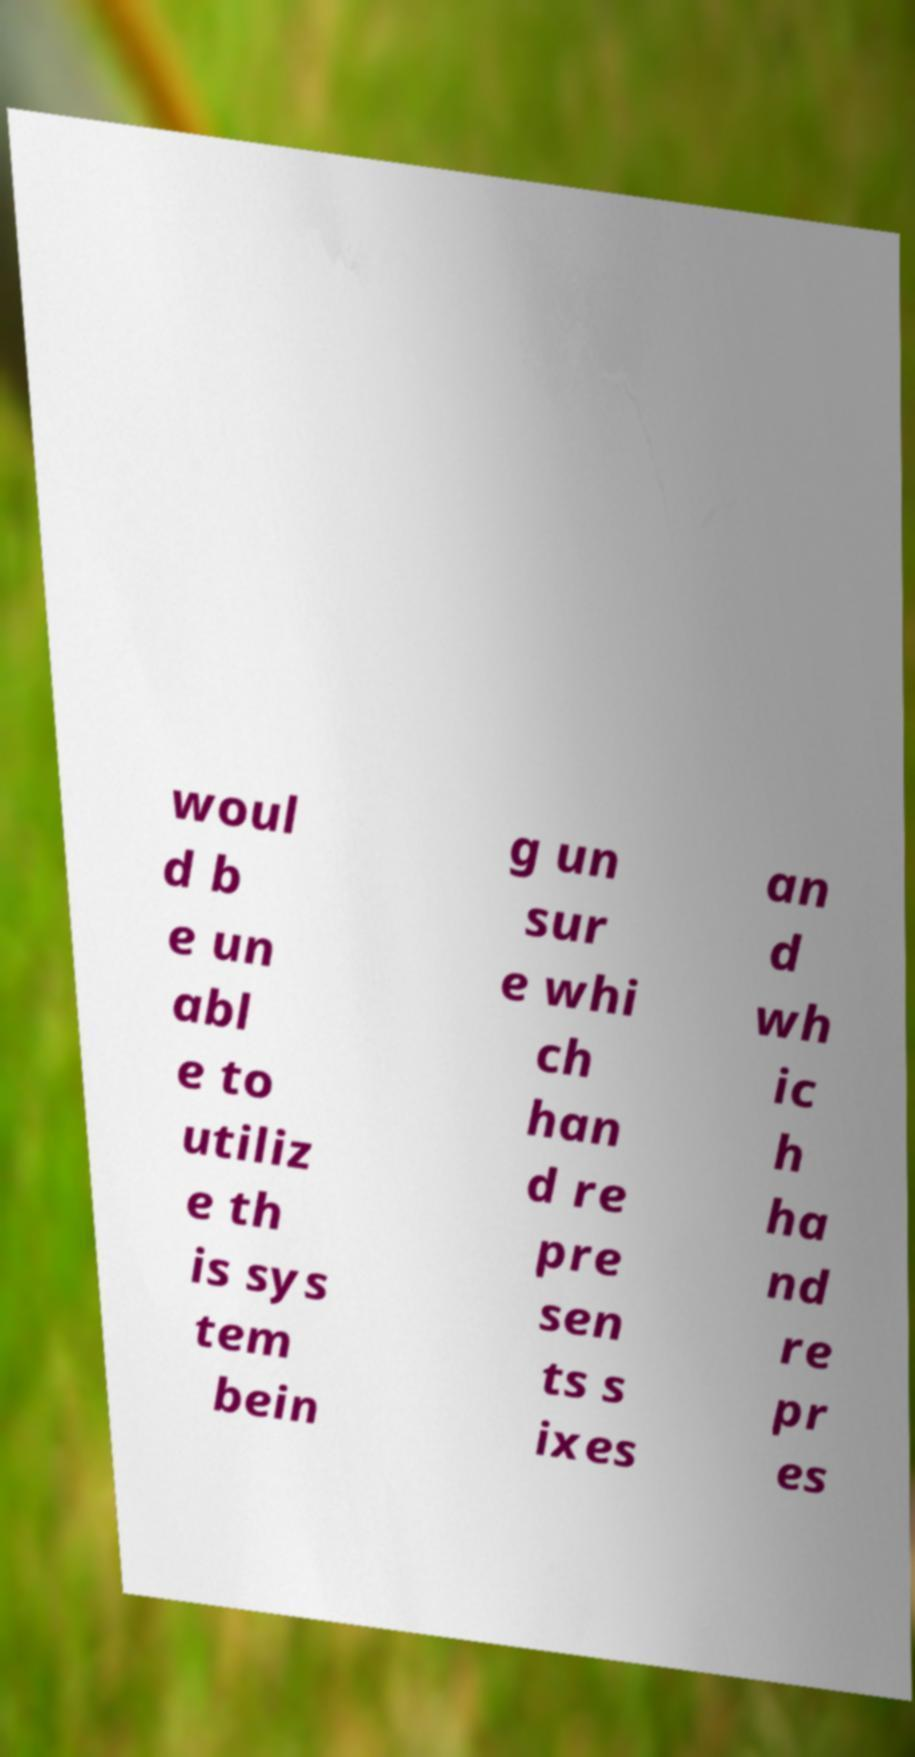Can you accurately transcribe the text from the provided image for me? woul d b e un abl e to utiliz e th is sys tem bein g un sur e whi ch han d re pre sen ts s ixes an d wh ic h ha nd re pr es 